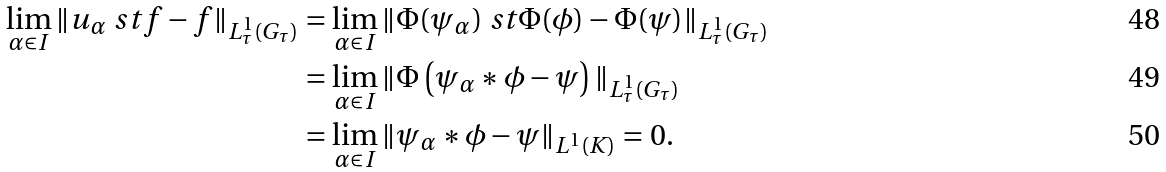<formula> <loc_0><loc_0><loc_500><loc_500>\lim _ { \alpha \in I } \| u _ { \alpha } \ s t f - f \| _ { L ^ { 1 } _ { \tau } ( G _ { \tau } ) } & = \lim _ { \alpha \in I } \| \Phi ( \psi _ { \alpha } ) \ s t \Phi ( \phi ) - \Phi ( \psi ) \| _ { L ^ { 1 } _ { \tau } ( G _ { \tau } ) } \\ & = \lim _ { \alpha \in I } \| \Phi \left ( \psi _ { \alpha } \ast \phi - \psi \right ) \| _ { L ^ { 1 } _ { \tau } ( G _ { \tau } ) } \\ & = \lim _ { \alpha \in I } \| \psi _ { \alpha } \ast \phi - \psi \| _ { L ^ { 1 } ( K ) } = 0 .</formula> 